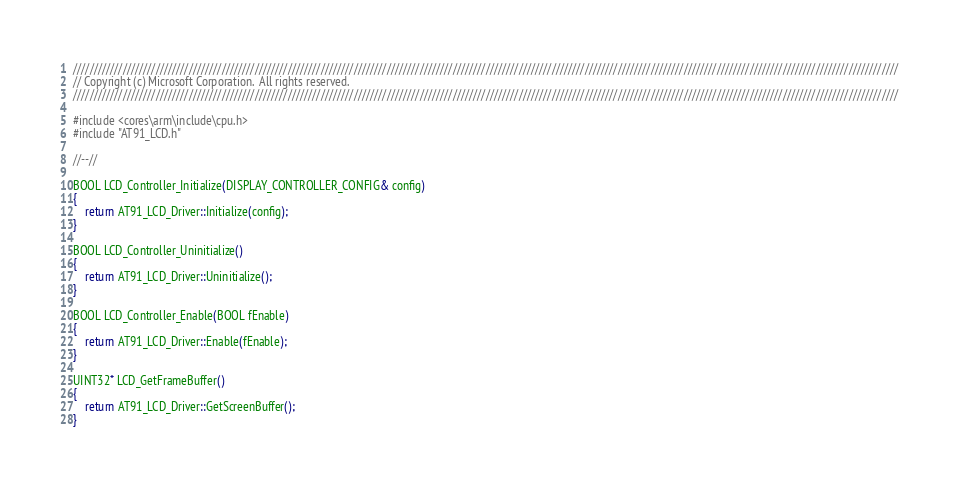<code> <loc_0><loc_0><loc_500><loc_500><_C++_>////////////////////////////////////////////////////////////////////////////////////////////////////////////////////////////////////////////////////////////////////////////////////////////////////////
// Copyright (c) Microsoft Corporation.  All rights reserved.
////////////////////////////////////////////////////////////////////////////////////////////////////////////////////////////////////////////////////////////////////////////////////////////////////////

#include <cores\arm\include\cpu.h>
#include "AT91_LCD.h"

//--//

BOOL LCD_Controller_Initialize(DISPLAY_CONTROLLER_CONFIG& config)
{
    return AT91_LCD_Driver::Initialize(config);
}

BOOL LCD_Controller_Uninitialize()
{
    return AT91_LCD_Driver::Uninitialize();
}

BOOL LCD_Controller_Enable(BOOL fEnable)
{
    return AT91_LCD_Driver::Enable(fEnable);
}

UINT32* LCD_GetFrameBuffer()
{
    return AT91_LCD_Driver::GetScreenBuffer();
}

</code> 